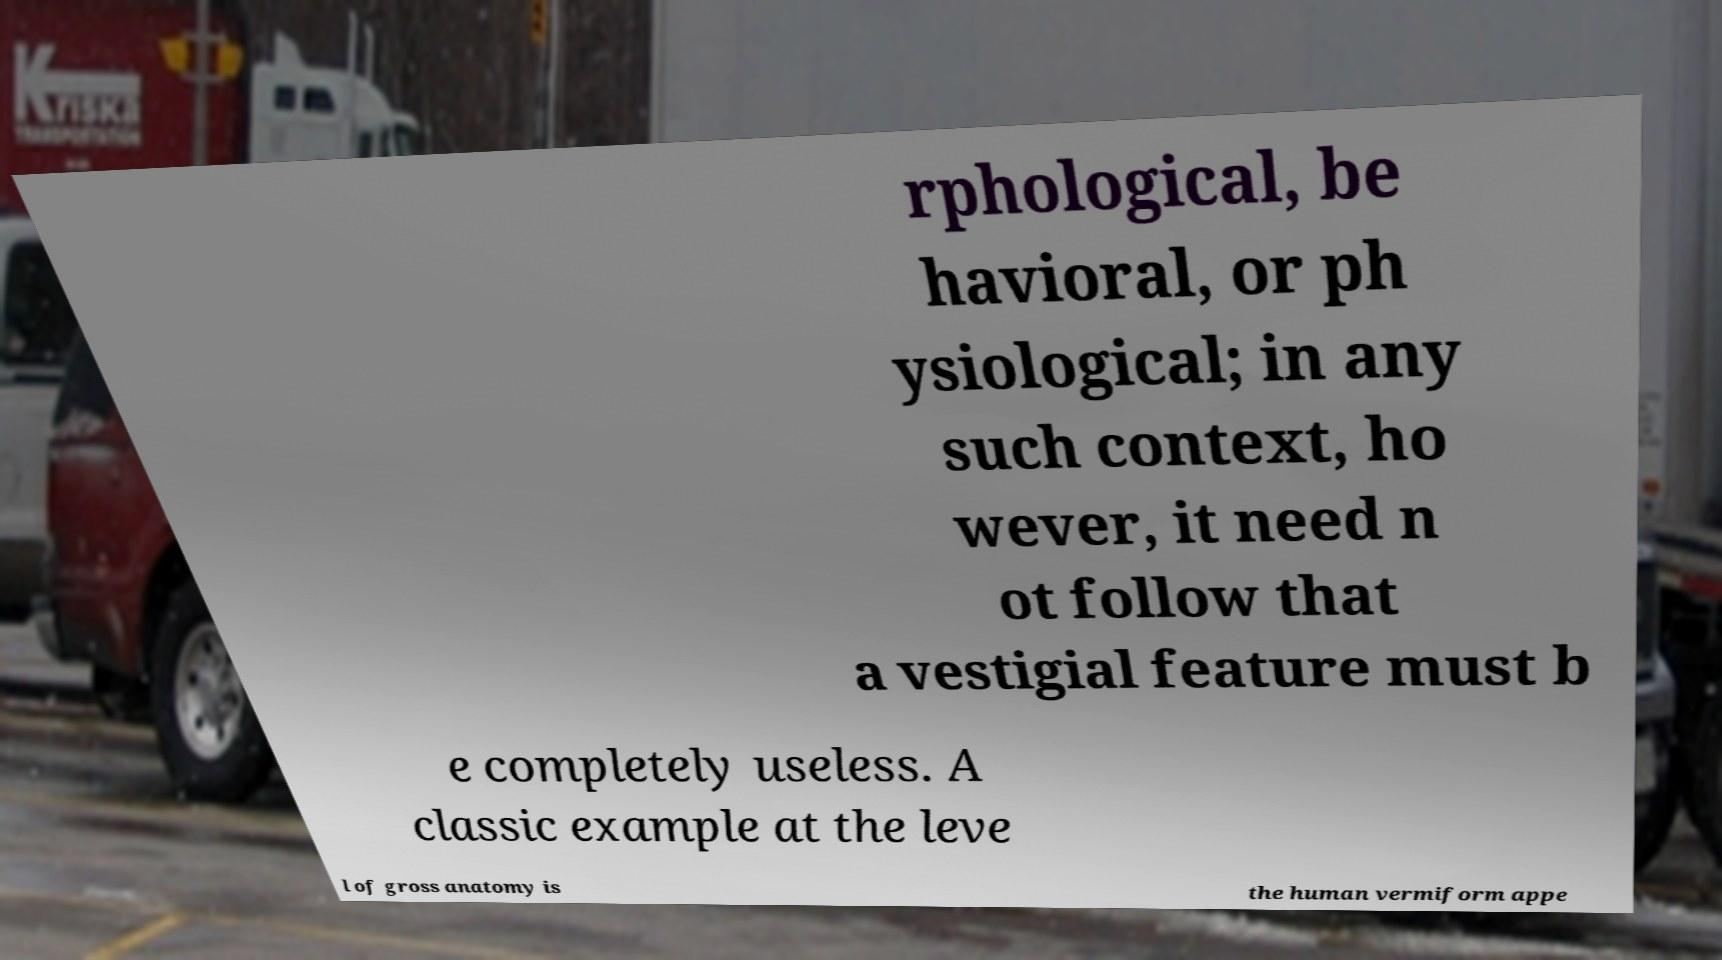Please identify and transcribe the text found in this image. rphological, be havioral, or ph ysiological; in any such context, ho wever, it need n ot follow that a vestigial feature must b e completely useless. A classic example at the leve l of gross anatomy is the human vermiform appe 